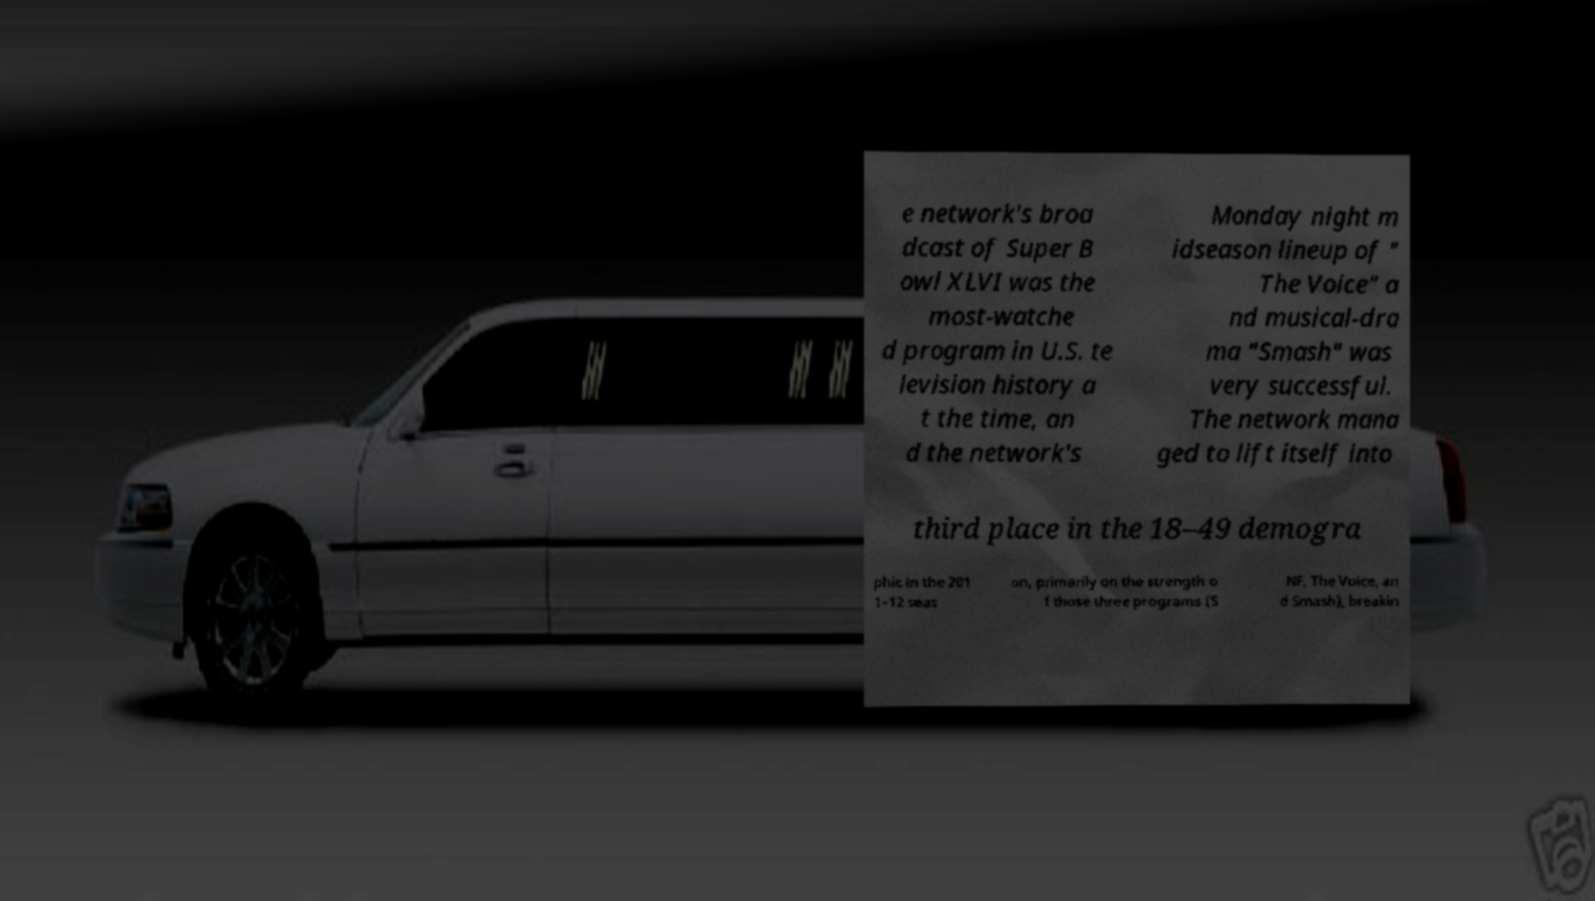What messages or text are displayed in this image? I need them in a readable, typed format. e network's broa dcast of Super B owl XLVI was the most-watche d program in U.S. te levision history a t the time, an d the network's Monday night m idseason lineup of " The Voice" a nd musical-dra ma "Smash" was very successful. The network mana ged to lift itself into third place in the 18–49 demogra phic in the 201 1–12 seas on, primarily on the strength o f those three programs (S NF, The Voice, an d Smash), breakin 